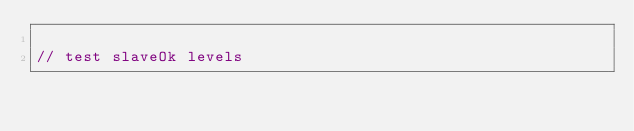Convert code to text. <code><loc_0><loc_0><loc_500><loc_500><_JavaScript_>
// test slaveOk levels</code> 